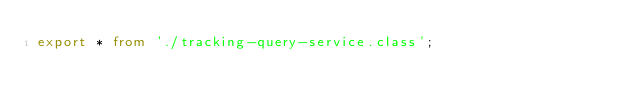<code> <loc_0><loc_0><loc_500><loc_500><_TypeScript_>export * from './tracking-query-service.class';
</code> 